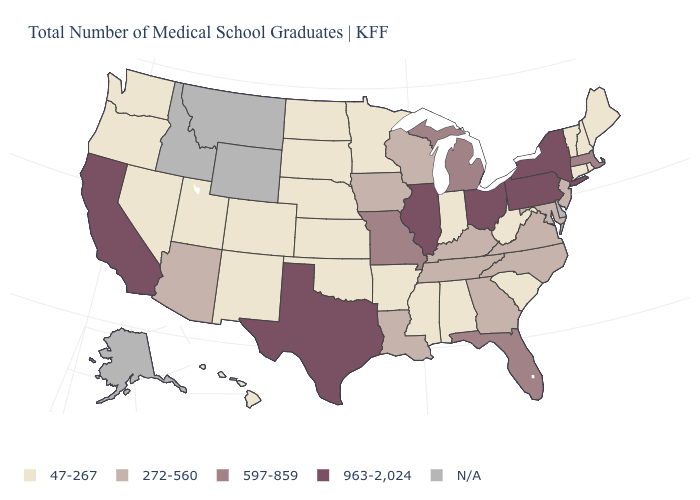Name the states that have a value in the range 272-560?
Give a very brief answer. Arizona, Georgia, Iowa, Kentucky, Louisiana, Maryland, New Jersey, North Carolina, Tennessee, Virginia, Wisconsin. What is the value of Connecticut?
Give a very brief answer. 47-267. Name the states that have a value in the range 47-267?
Short answer required. Alabama, Arkansas, Colorado, Connecticut, Hawaii, Indiana, Kansas, Maine, Minnesota, Mississippi, Nebraska, Nevada, New Hampshire, New Mexico, North Dakota, Oklahoma, Oregon, Rhode Island, South Carolina, South Dakota, Utah, Vermont, Washington, West Virginia. Name the states that have a value in the range 272-560?
Be succinct. Arizona, Georgia, Iowa, Kentucky, Louisiana, Maryland, New Jersey, North Carolina, Tennessee, Virginia, Wisconsin. Which states hav the highest value in the MidWest?
Be succinct. Illinois, Ohio. Name the states that have a value in the range 597-859?
Give a very brief answer. Florida, Massachusetts, Michigan, Missouri. What is the value of New Hampshire?
Answer briefly. 47-267. Does Illinois have the highest value in the USA?
Give a very brief answer. Yes. Among the states that border New Jersey , which have the highest value?
Keep it brief. New York, Pennsylvania. What is the value of Illinois?
Quick response, please. 963-2,024. How many symbols are there in the legend?
Be succinct. 5. What is the highest value in the USA?
Write a very short answer. 963-2,024. Does Hawaii have the highest value in the USA?
Give a very brief answer. No. What is the value of Maryland?
Quick response, please. 272-560. 